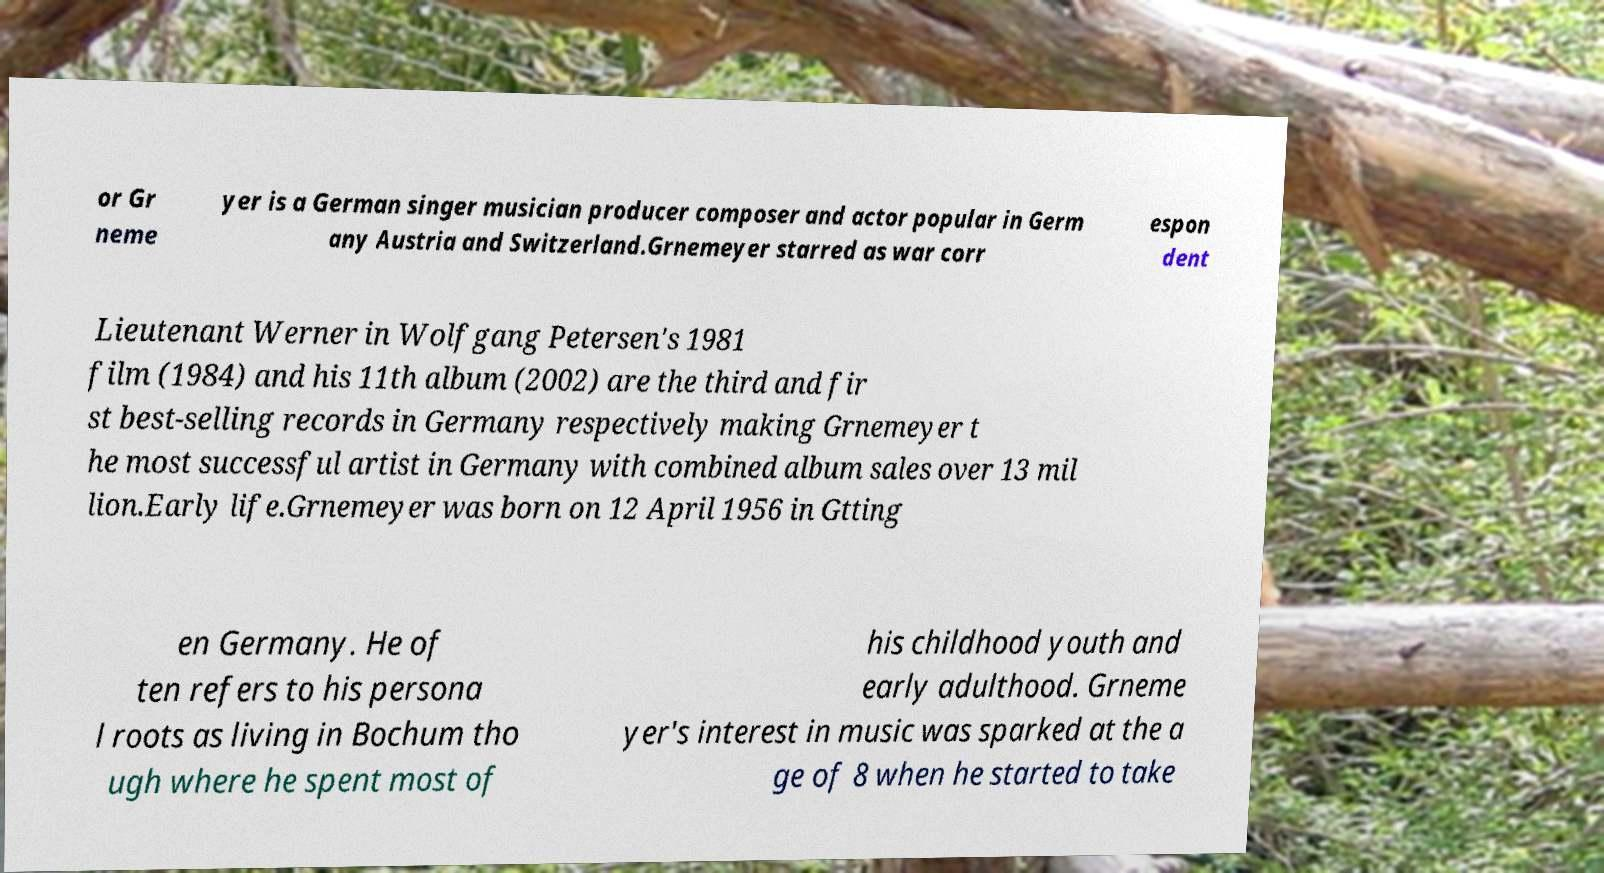I need the written content from this picture converted into text. Can you do that? or Gr neme yer is a German singer musician producer composer and actor popular in Germ any Austria and Switzerland.Grnemeyer starred as war corr espon dent Lieutenant Werner in Wolfgang Petersen's 1981 film (1984) and his 11th album (2002) are the third and fir st best-selling records in Germany respectively making Grnemeyer t he most successful artist in Germany with combined album sales over 13 mil lion.Early life.Grnemeyer was born on 12 April 1956 in Gtting en Germany. He of ten refers to his persona l roots as living in Bochum tho ugh where he spent most of his childhood youth and early adulthood. Grneme yer's interest in music was sparked at the a ge of 8 when he started to take 